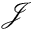Convert formula to latex. <formula><loc_0><loc_0><loc_500><loc_500>\mathcal { J }</formula> 